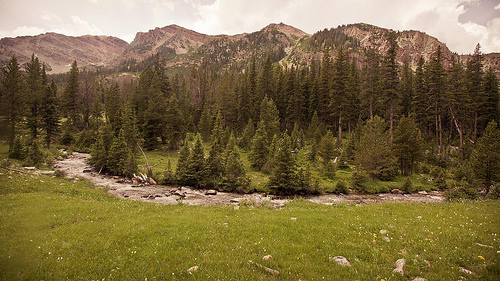<image>
Can you confirm if the tree is on the mountain? No. The tree is not positioned on the mountain. They may be near each other, but the tree is not supported by or resting on top of the mountain. 